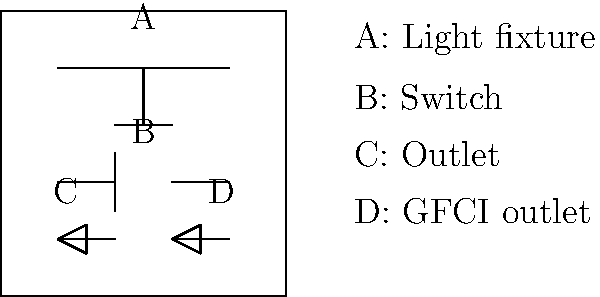In the given ranch wiring schematic, identify the components labeled A, B, C, and D. Which of these components is crucial for outdoor areas near water sources, such as a horse trough or outdoor sink? Let's break down the components in the schematic:

1. Component A: This symbol represents a light fixture. It's shown as a horizontal line with a circle in the middle, which is the standard symbol for a ceiling light.

2. Component B: This symbol represents a switch. It's depicted as a break in the circuit line with two small perpendicular lines, indicating where the circuit can be opened or closed.

3. Component C: This symbol represents a standard electrical outlet. It's shown as a circle with two T-shaped lines, representing the two slots in a typical outlet.

4. Component D: This symbol represents a Ground Fault Circuit Interrupter (GFCI) outlet. It's similar to the standard outlet symbol but with an additional line, indicating its special protective function.

For areas near water sources on a ranch, such as near a horse trough or outdoor sink, a GFCI outlet (Component D) is crucial. GFCI outlets are designed to protect against ground faults, which can occur when electricity finds an unintended path to ground, often through water or a person. They quickly shut off power when they detect a ground fault, reducing the risk of electric shock in wet environments.

Therefore, the component crucial for outdoor areas near water sources is D, the GFCI outlet.
Answer: D (GFCI outlet) 